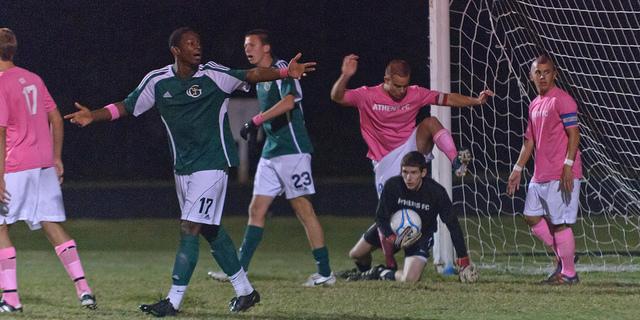How old are the players?
Quick response, please. 20's. Is this sport in the Summer Olympics?
Answer briefly. Yes. What color is the man's shirt that is stepping over the goalie?
Quick response, please. Pink. Is this a soccer match?
Concise answer only. Yes. Do you see a net?
Short answer required. Yes. Is this actually three separate pictures?
Short answer required. No. Is this a professional player?
Be succinct. Yes. 